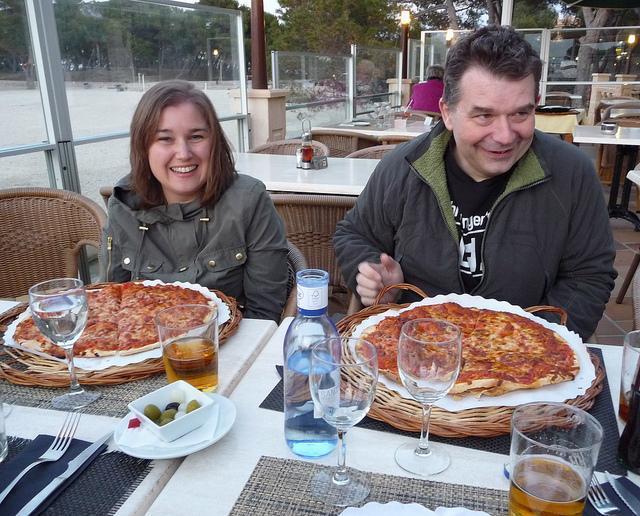How many dining tables are in the photo?
Give a very brief answer. 4. How many chairs are there?
Give a very brief answer. 3. How many pizzas are in the picture?
Give a very brief answer. 2. How many wine glasses are in the picture?
Give a very brief answer. 3. How many people can you see?
Give a very brief answer. 2. How many cups can you see?
Give a very brief answer. 2. How many boats are in the water?
Give a very brief answer. 0. 